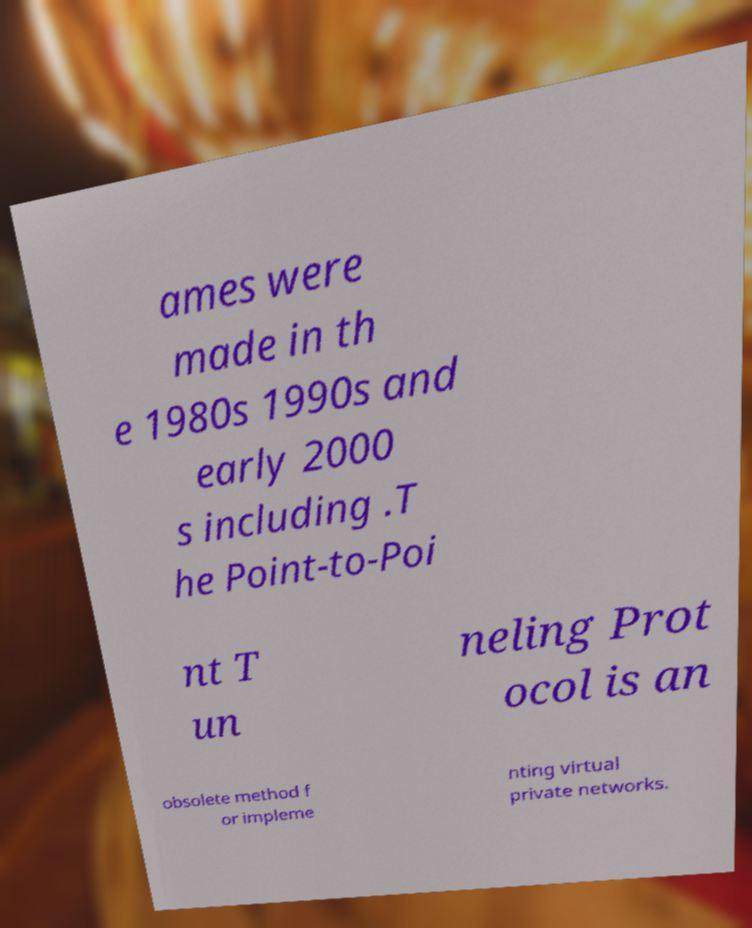Can you accurately transcribe the text from the provided image for me? ames were made in th e 1980s 1990s and early 2000 s including .T he Point-to-Poi nt T un neling Prot ocol is an obsolete method f or impleme nting virtual private networks. 